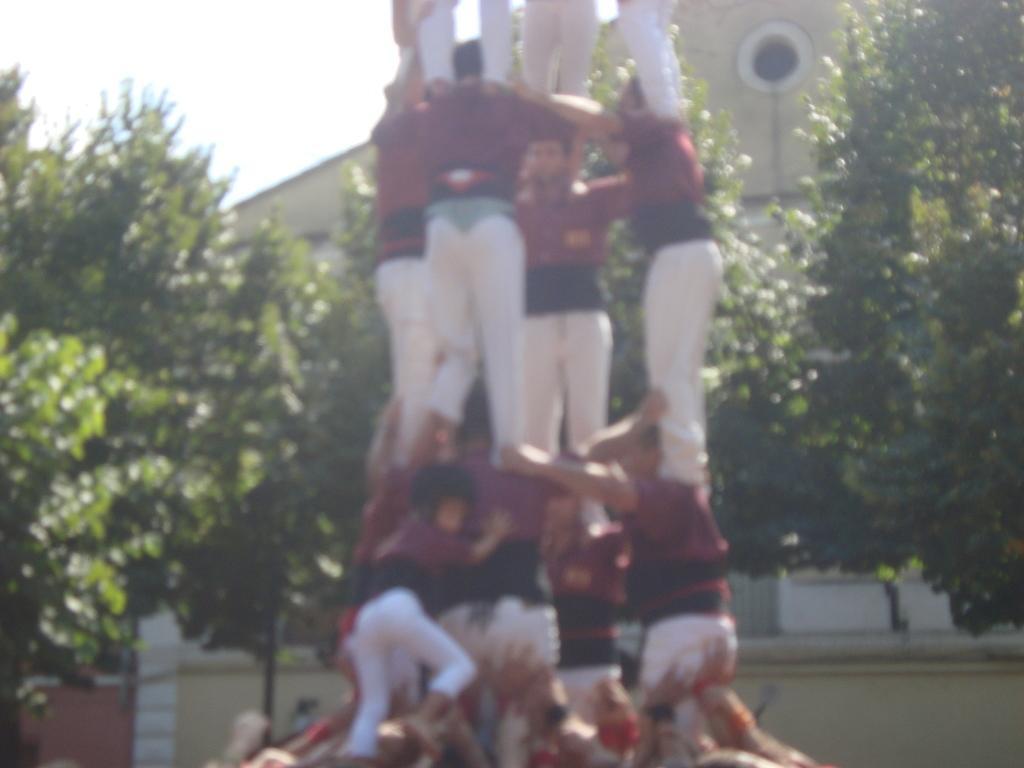Describe this image in one or two sentences. In the image few people are standing like a tower. Behind them there are some trees and buildings. Top left side of the image there is sky. 